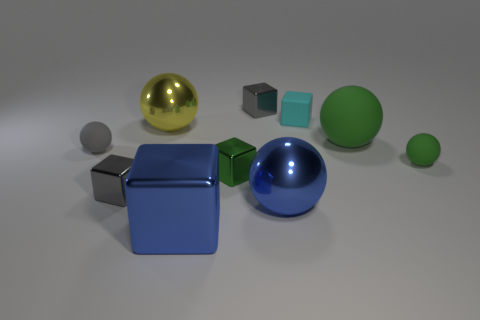What size is the green metallic thing that is the same shape as the tiny cyan object?
Provide a succinct answer. Small. Do the green shiny object and the rubber cube have the same size?
Offer a very short reply. Yes. The blue metal object that is right of the tiny gray block that is right of the metal sphere that is behind the big rubber thing is what shape?
Provide a short and direct response. Sphere. There is a big matte object that is the same shape as the tiny green matte object; what is its color?
Ensure brevity in your answer.  Green. There is a matte sphere that is behind the small green ball and on the right side of the big yellow object; what size is it?
Make the answer very short. Large. How many yellow spheres are behind the tiny gray block behind the tiny block right of the big blue ball?
Your answer should be compact. 0. How many tiny things are red rubber cylinders or green cubes?
Make the answer very short. 1. Does the cyan thing that is to the left of the large green rubber thing have the same material as the yellow object?
Give a very brief answer. No. The small sphere on the left side of the small gray object behind the matte thing that is left of the cyan cube is made of what material?
Provide a short and direct response. Rubber. How many metal objects are small cubes or big brown cubes?
Your response must be concise. 3. 